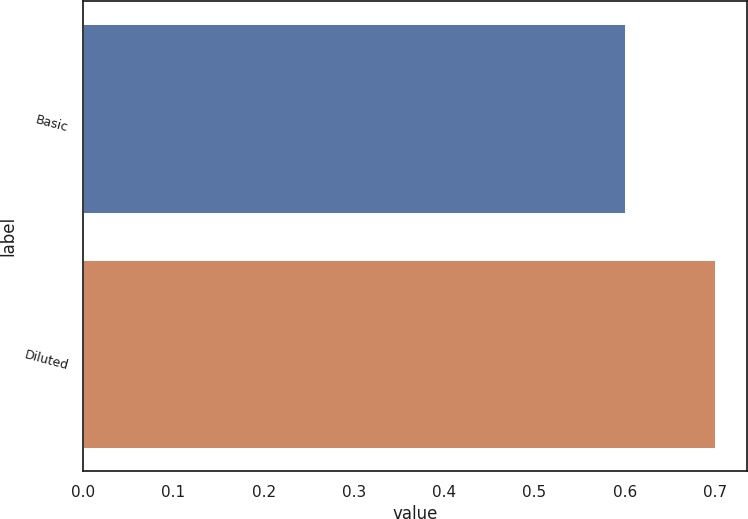<chart> <loc_0><loc_0><loc_500><loc_500><bar_chart><fcel>Basic<fcel>Diluted<nl><fcel>0.6<fcel>0.7<nl></chart> 